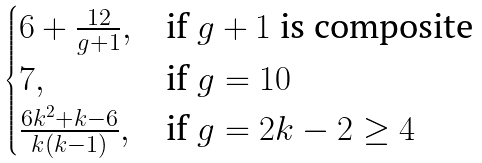<formula> <loc_0><loc_0><loc_500><loc_500>\begin{cases} 6 + \frac { 1 2 } { g + 1 } , & \text {if } g + 1 \text { is composite} \\ 7 , & \text {if } g = 1 0 \\ \frac { 6 k ^ { 2 } + k - 6 } { k ( k - 1 ) } , & \text {if } g = 2 k - 2 \geq 4 \end{cases}</formula> 